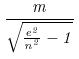Convert formula to latex. <formula><loc_0><loc_0><loc_500><loc_500>\frac { m } { \sqrt { \frac { e ^ { 2 } } { n ^ { 2 } } - 1 } }</formula> 